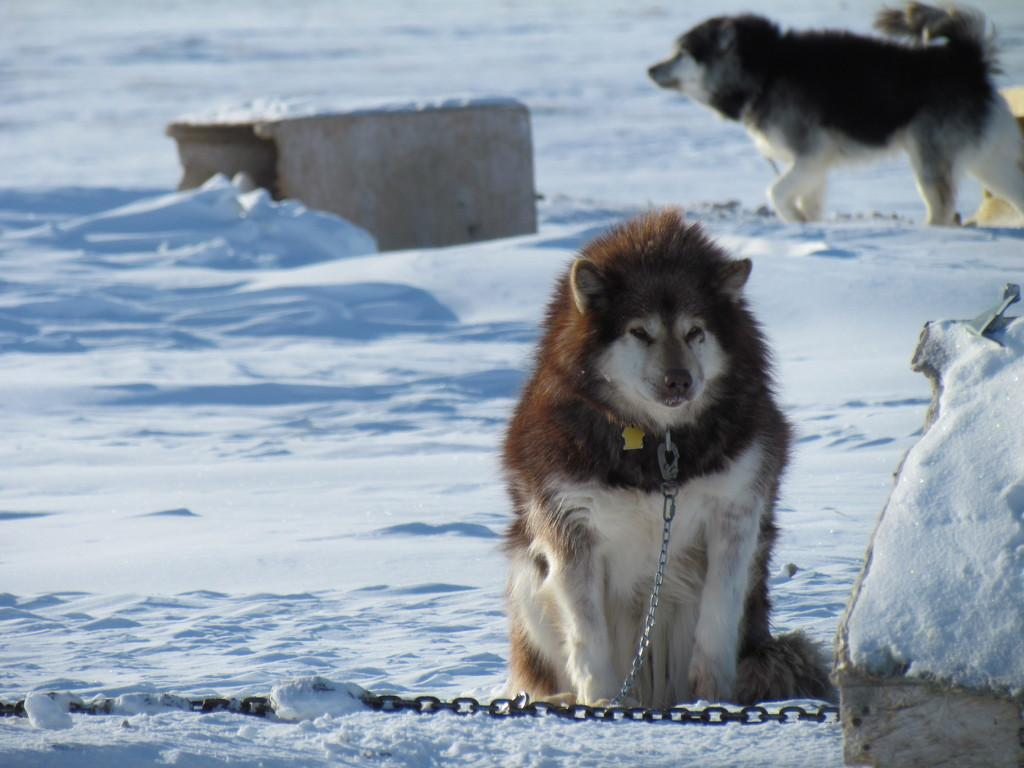What is the condition of the ground in the image? There is snow on the ground in the image. What is the dog in the image doing? The dog in the image has a chain, suggesting it is tethered to something. What is the chain connected to in the image? The chain is on the snow in the image. What can be seen in the background of the image? There is a block and another dog in the background of the image. What type of baseball can be seen in the dog's pocket in the image? There is no baseball or pocket present in the image; it features a dog with a chain on the snow. 